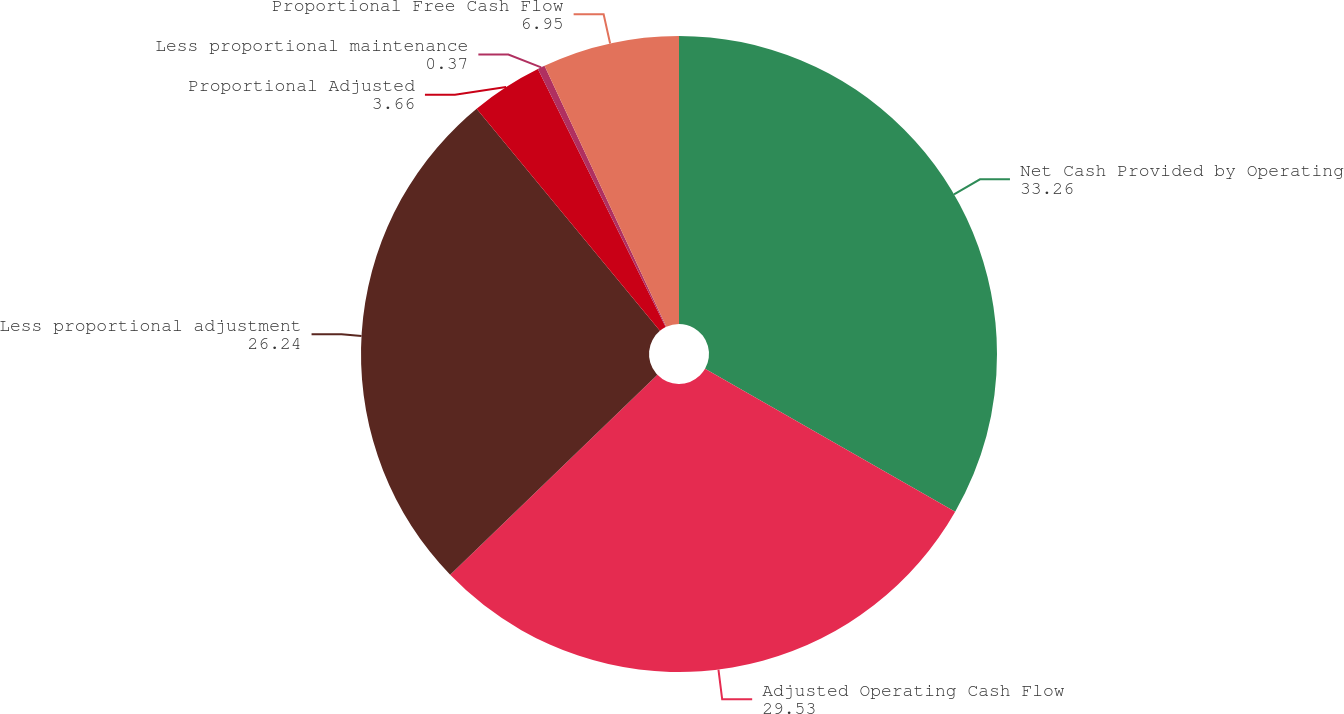Convert chart to OTSL. <chart><loc_0><loc_0><loc_500><loc_500><pie_chart><fcel>Net Cash Provided by Operating<fcel>Adjusted Operating Cash Flow<fcel>Less proportional adjustment<fcel>Proportional Adjusted<fcel>Less proportional maintenance<fcel>Proportional Free Cash Flow<nl><fcel>33.26%<fcel>29.53%<fcel>26.24%<fcel>3.66%<fcel>0.37%<fcel>6.95%<nl></chart> 